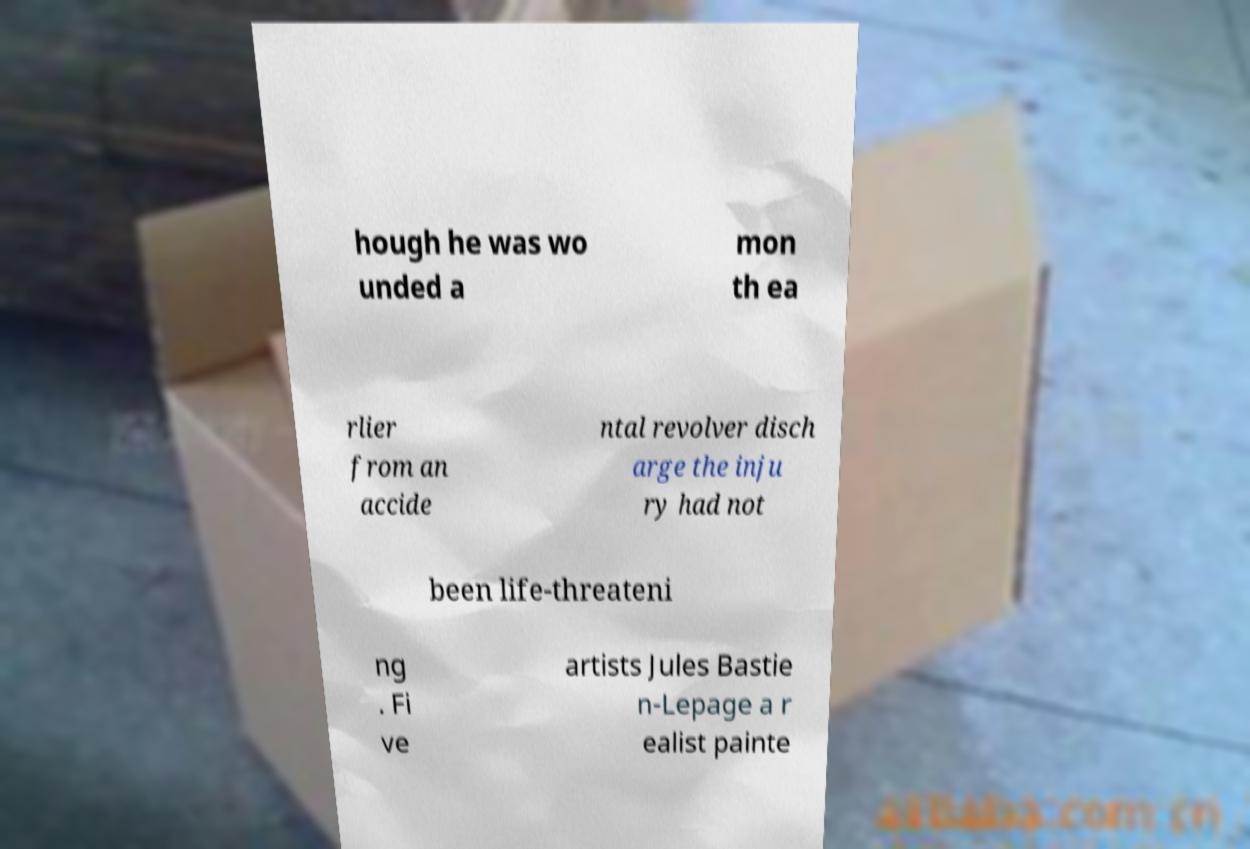Please read and relay the text visible in this image. What does it say? hough he was wo unded a mon th ea rlier from an accide ntal revolver disch arge the inju ry had not been life-threateni ng . Fi ve artists Jules Bastie n-Lepage a r ealist painte 